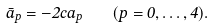<formula> <loc_0><loc_0><loc_500><loc_500>\bar { a } _ { p } = - 2 c a _ { p } \quad ( p = 0 , \dots , 4 ) .</formula> 